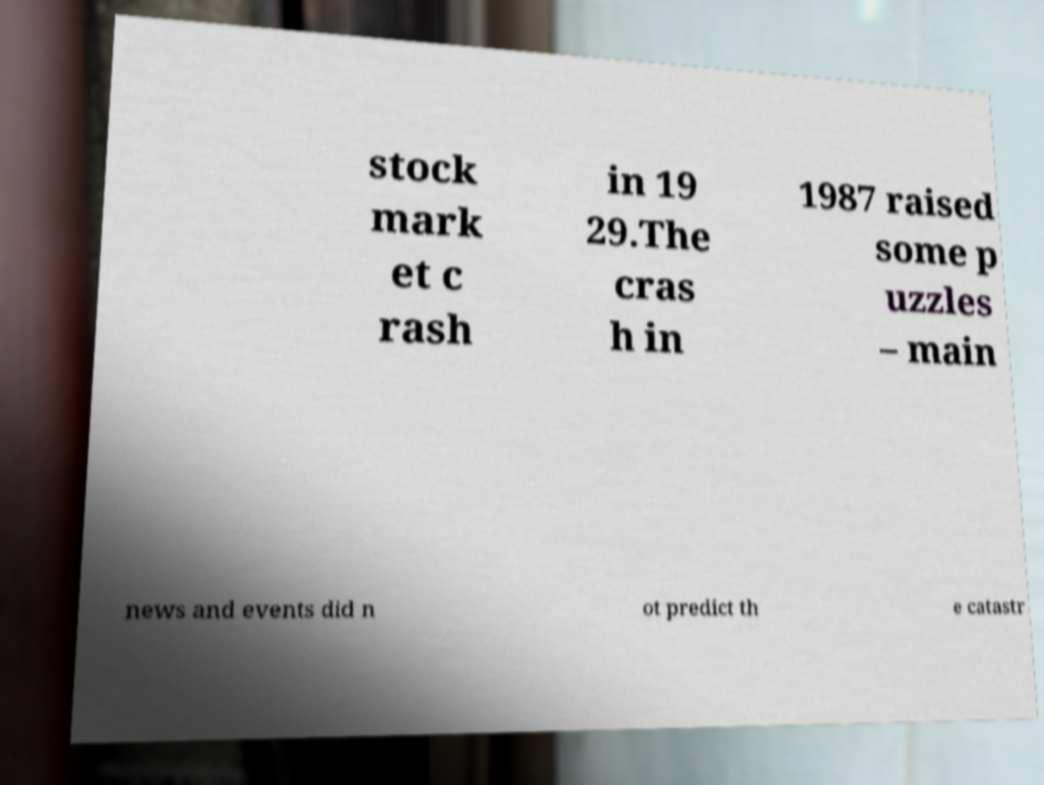What messages or text are displayed in this image? I need them in a readable, typed format. stock mark et c rash in 19 29.The cras h in 1987 raised some p uzzles – main news and events did n ot predict th e catastr 